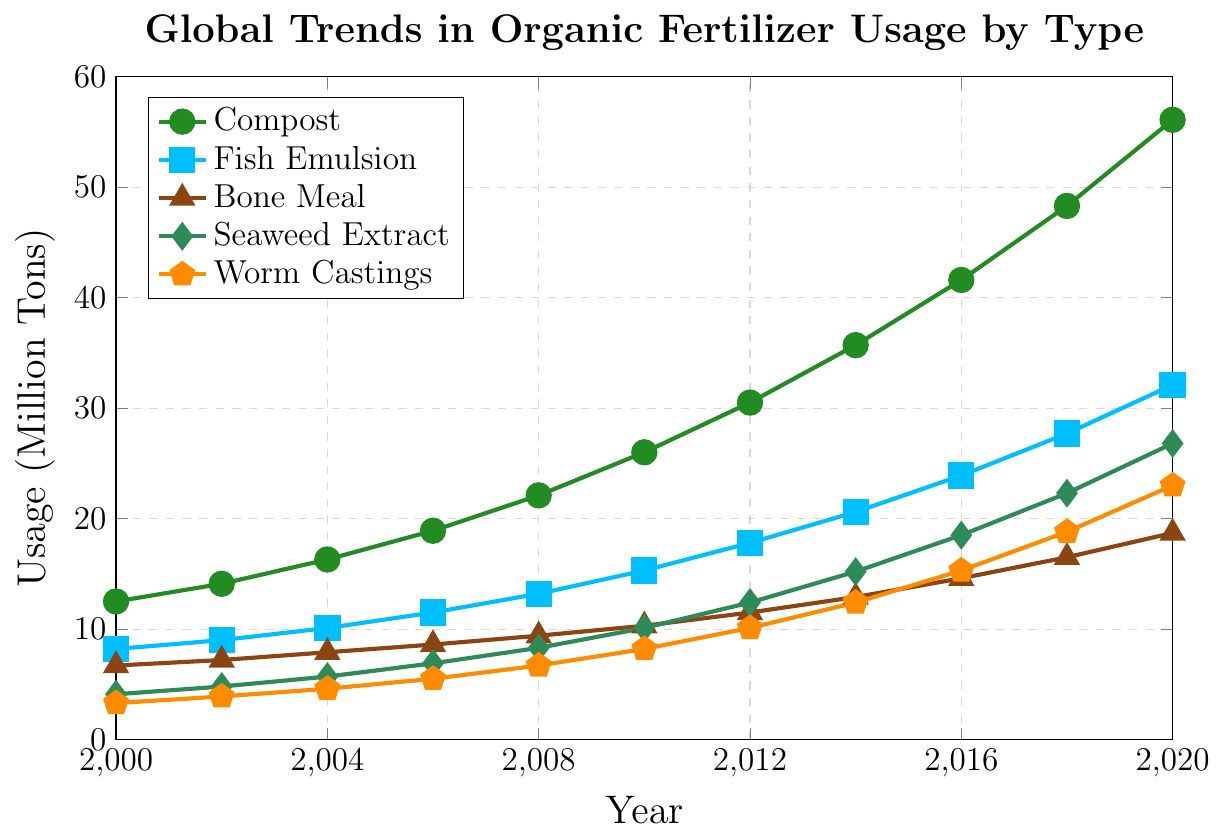What is the usage of Fish Emulsion in 2010? Find Fish Emulsion in the legend. Look at the value corresponding to 2010 on the Fish Emulsion line.
Answer: 15.3 million tons How much did the Bone Meal usage increase from 2000 to 2020? Find Bone Meal in the legend. Subtract the 2000 value from the 2020 value on the Bone Meal line: 18.7 - 6.7 = 12
Answer: 12 million tons Which organic fertilizer had the highest usage in 2020? Identify the highest value on the y-axis for the year 2020 and see which line reaches there.
Answer: Compost Is the usage of Seaweed Extract above or below 10 million tons in 2010? Find Seaweed Extract in the legend. Look at the point for 2010 and see if it is above or below 10 on the y-axis.
Answer: Above By how much did the usage of Worm Castings increase from 2006 to 2012? Find Worm Castings in the legend. Subtract the 2006 value from the 2012 value on the Worm Castings line: 10.1 - 5.5 = 4.6
Answer: 4.6 million tons Calculate the average usage of Compost over the years 2000, 2004, and 2008. Sum the values for Compost in the years 2000, 2004, and 2008: 12.5 + 16.3 + 22.1 = 50.9. Divide by 3: 50.9 / 3 ≈ 17.0
Answer: 17.0 million tons Compare the usage of Fish Emulsion and Seaweed Extract in 2016. Which was higher and by how much? Find Fish Emulsion and Seaweed Extract in the legend. Compare their values for 2016: 23.9 (Fish Emulsion) - 18.5 (Seaweed Extract) = 5.4. Fish Emulsion is higher.
Answer: Fish Emulsion by 5.4 million tons What is the trend of Compost usage from 2000 to 2020? Observe the Compost line from 2000 to 2020. Describe the general direction: Increasing consistently.
Answer: Increasing consistently In which year did Bone Meal usage first exceed 10 million tons? Find Bone Meal in the legend. Look for the first year where the y-value exceeds 10: 2010
Answer: 2010 What is the total combined usage of all fertilizers in 2018? Sum the values of all fertilizers in 2018: 48.3 + 27.7 + 16.5 + 22.3 + 18.8. Total = 133.6
Answer: 133.6 million tons 